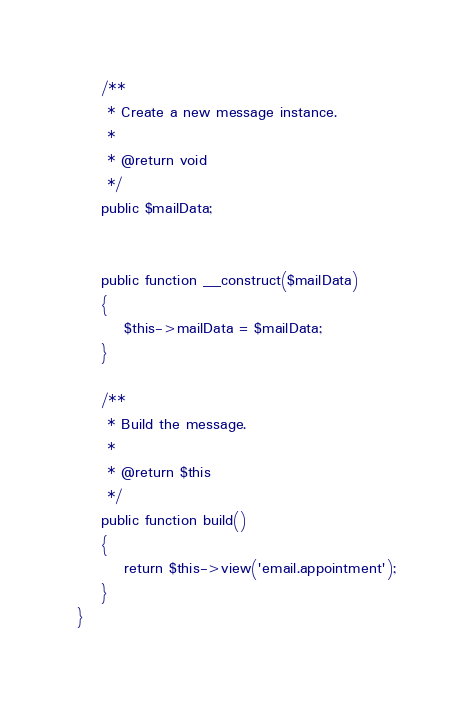Convert code to text. <code><loc_0><loc_0><loc_500><loc_500><_PHP_>
    /**
     * Create a new message instance.
     *
     * @return void
     */
    public $mailData;
    

    public function __construct($mailData)
    {
        $this->mailData = $mailData;
    }

    /**
     * Build the message.
     *
     * @return $this
     */
    public function build()
    {
        return $this->view('email.appointment');
    }
}
</code> 